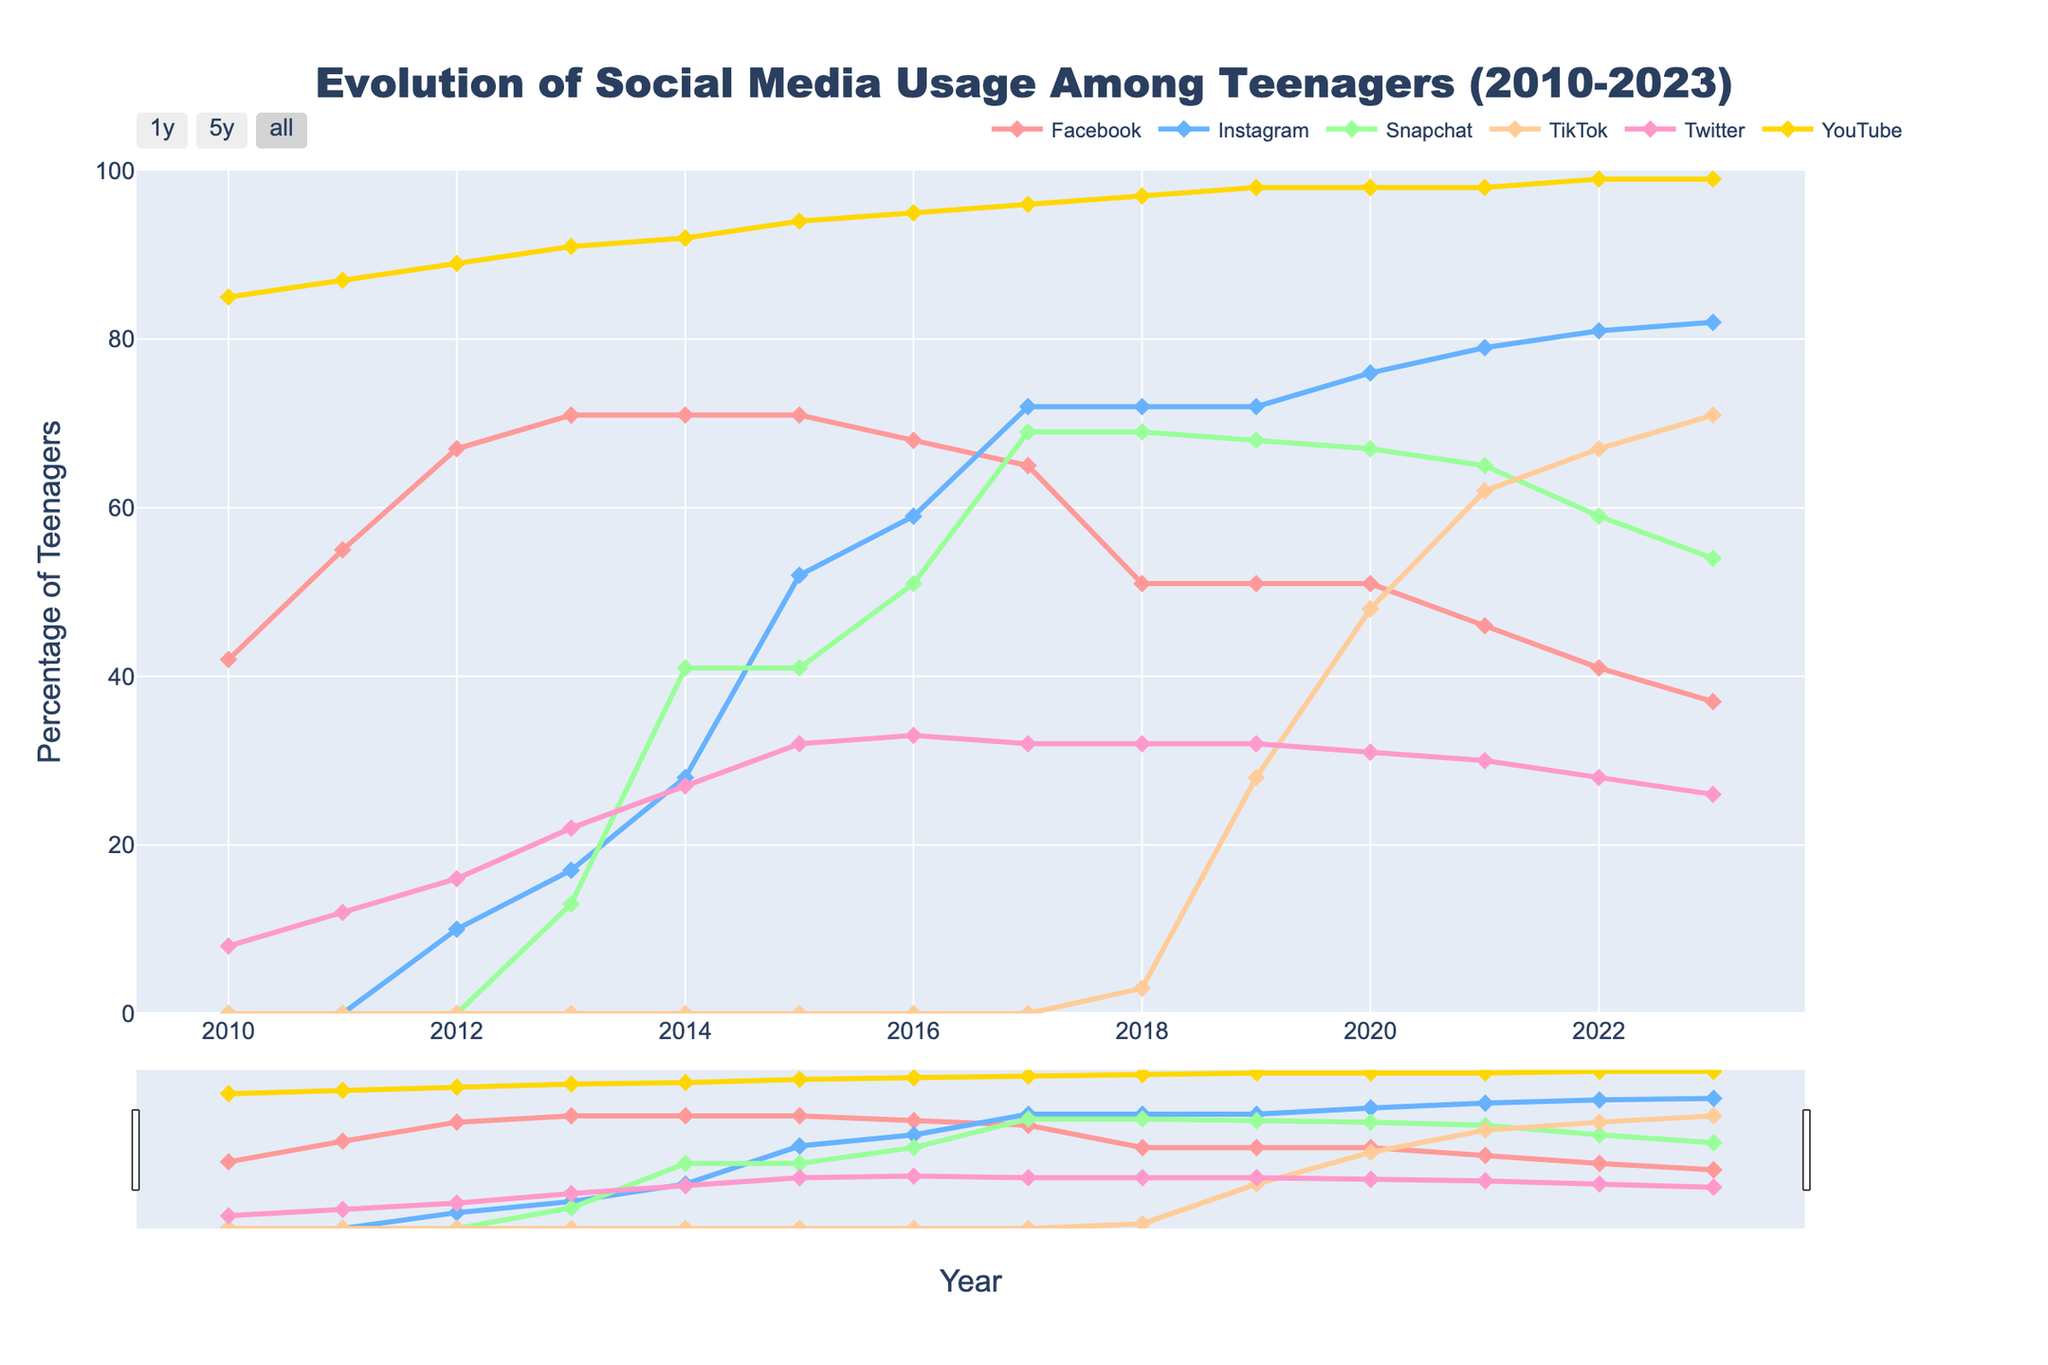What trend can you observe for Facebook usage from 2010 to 2023? The figure shows that Facebook usage among teenagers peaked around 2013-2015 and then gradually declined. In 2010, usage was at 42%, increased to 71% by 2013, and then dropped to 37% by 2023.
Answer: Decline When did Instagram usage among teenagers surpass Facebook usage? Instagram usage surpassed Facebook usage in 2017. In 2017, Instagram had 72% usage while Facebook had 65%.
Answer: 2017 What social media platform has seen the most significant increase in usage since its introduction? TikTok has seen the most significant increase since its introduction in 2018 with 3%, climbing to 71% by 2023.
Answer: TikTok Compare the usage of Snapchat and TikTok in 2020. Which platform was more popular? The figure shows that in 2020, Snapchat had 67% usage while TikTok had 48% usage. Therefore, Snapchat was more popular in that year.
Answer: Snapchat How has YouTube usage changed over the years? YouTube usage has consistently increased over the years, starting from 85% in 2010 to 99% by 2023.
Answer: Increased In which year did Snapchat usage reach its peak, and what was the percentage? Snapchat usage peaked in 2017, with a usage rate of 69%.
Answer: 2017, 69% What was the combined usage percentage of Facebook and Instagram in 2014? In 2014, Facebook had 71% usage and Instagram had 28% usage. The combined usage percentage is 71 + 28 = 99%.
Answer: 99% How did Twitter's popularity change from 2014 to 2015? The figure shows a steady increase in Twitter's popularity from 2014 (27%) to 2015 (32%).
Answer: Increased What can you infer about the popularity trends of Facebook and TikTok from 2018 to 2023? From 2018 to 2023, Facebook's popularity declined from 51% to 37%, whereas TikTok's popularity increased from 3% to 71%.
Answer: Facebook declined; TikTok increased By how many percentage points did YouTube usage increase from 2012 to 2023? YouTube usage increased from 89% in 2012 to 99% in 2023. The increase is 99 - 89 = 10 percentage points.
Answer: 10 percentage points 